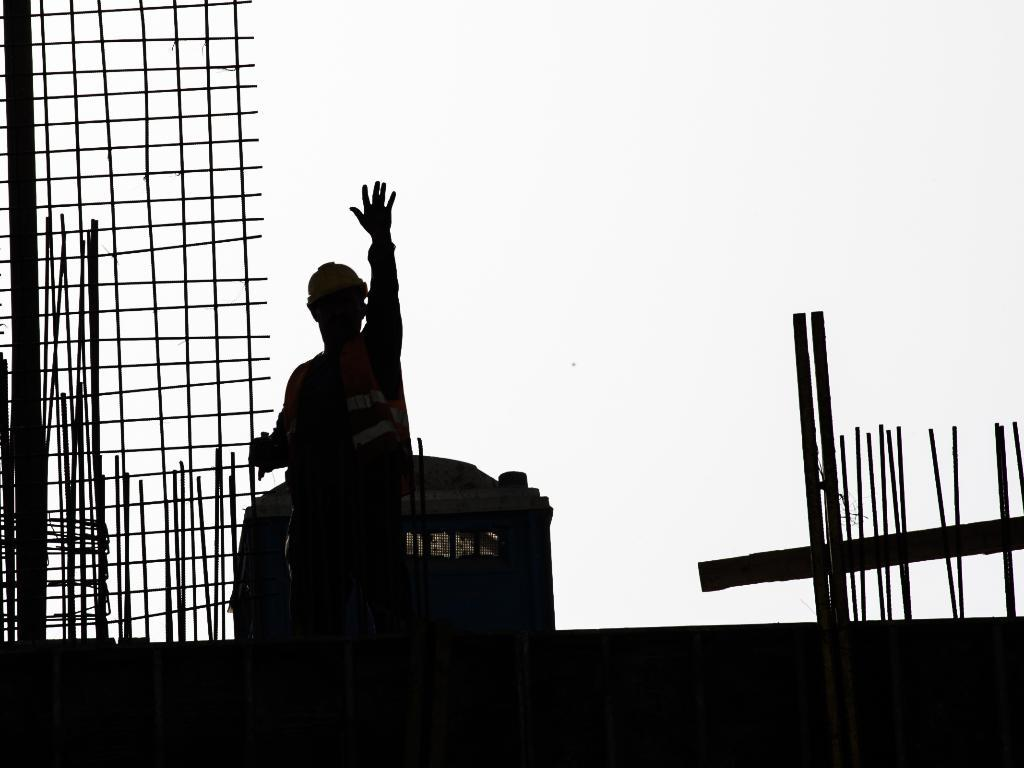What is the main subject of the image? There is a person in the image. What can be seen in the background of the image? There are rods and the sky visible in the background of the image. How would you describe the lighting in the image? The image appears to be dark. How many tomatoes are hanging from the rods in the image? There are no tomatoes present in the image; only rods and the sky are visible in the background. Can you tell me what type of bulb is used in the image? There is no bulb present in the image. 